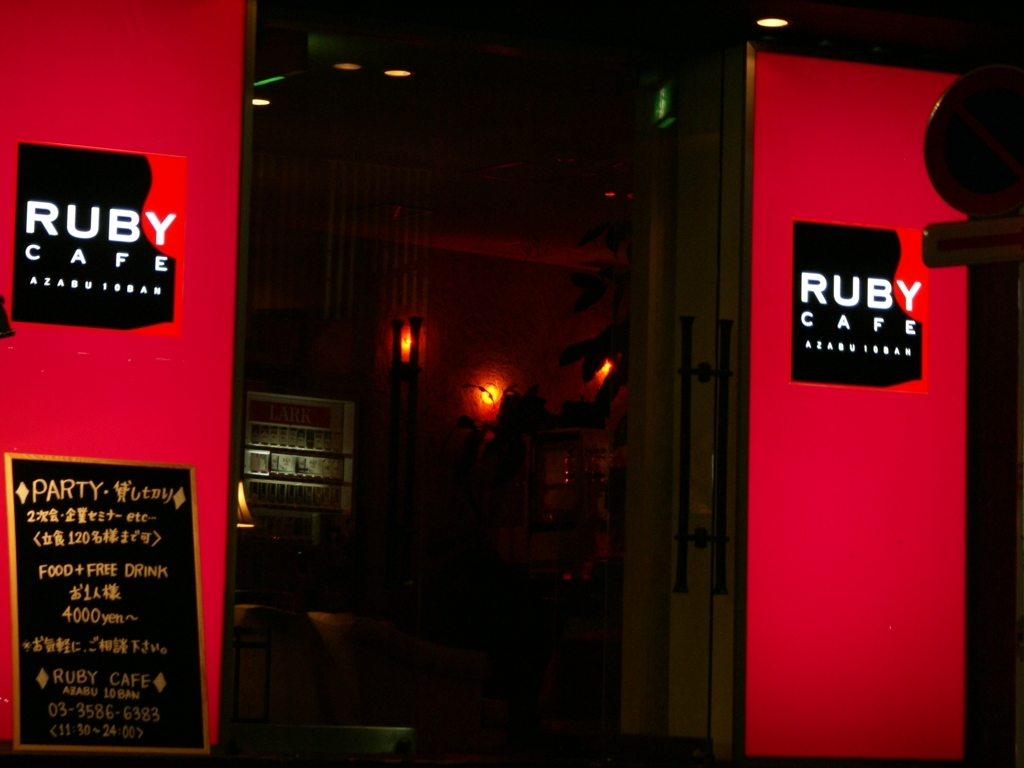Are there any details that indicate the location of this café? Yes, the sign includes the text 'AZABU 10BAN,' which suggests that the café is situated in Azabujuban, a district in Tokyo, Japan. This detail, combined with the phone number that follows the typical Japanese format, reinforces the café's geographic context. 